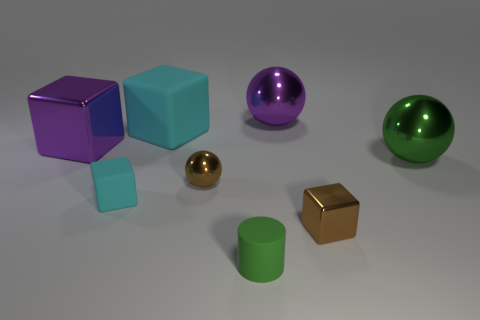What number of objects are either big yellow things or small blocks?
Keep it short and to the point. 2. There is a green cylinder; is it the same size as the purple block that is on the left side of the green rubber cylinder?
Your answer should be very brief. No. What is the color of the matte object behind the brown thing that is behind the matte cube that is left of the big cyan matte object?
Ensure brevity in your answer.  Cyan. What is the color of the tiny metal cube?
Make the answer very short. Brown. Is the number of rubber cubes behind the large purple metal cube greater than the number of small shiny balls left of the small metal sphere?
Your response must be concise. Yes. There is a tiny green rubber object; does it have the same shape as the brown object that is on the right side of the brown ball?
Your response must be concise. No. Does the cyan block that is in front of the small shiny sphere have the same size as the green thing that is to the right of the tiny green rubber object?
Give a very brief answer. No. Are there any big green metallic things that are to the left of the brown object that is in front of the cyan object in front of the large green ball?
Offer a terse response. No. Are there fewer small green matte things that are in front of the green cylinder than brown metallic things in front of the small brown block?
Your response must be concise. No. What is the shape of the other cyan object that is made of the same material as the big cyan thing?
Offer a very short reply. Cube. 